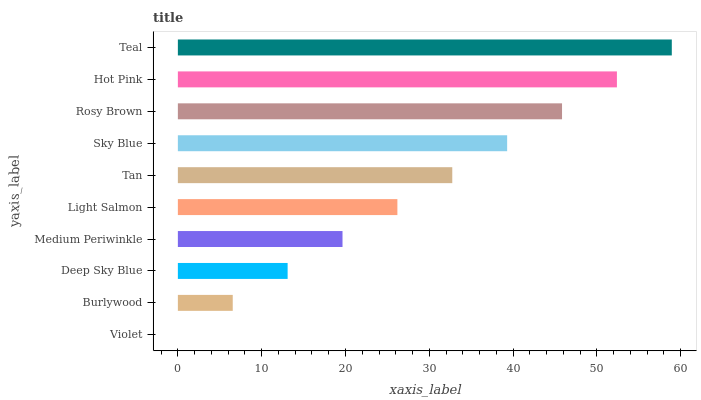Is Violet the minimum?
Answer yes or no. Yes. Is Teal the maximum?
Answer yes or no. Yes. Is Burlywood the minimum?
Answer yes or no. No. Is Burlywood the maximum?
Answer yes or no. No. Is Burlywood greater than Violet?
Answer yes or no. Yes. Is Violet less than Burlywood?
Answer yes or no. Yes. Is Violet greater than Burlywood?
Answer yes or no. No. Is Burlywood less than Violet?
Answer yes or no. No. Is Tan the high median?
Answer yes or no. Yes. Is Light Salmon the low median?
Answer yes or no. Yes. Is Light Salmon the high median?
Answer yes or no. No. Is Sky Blue the low median?
Answer yes or no. No. 